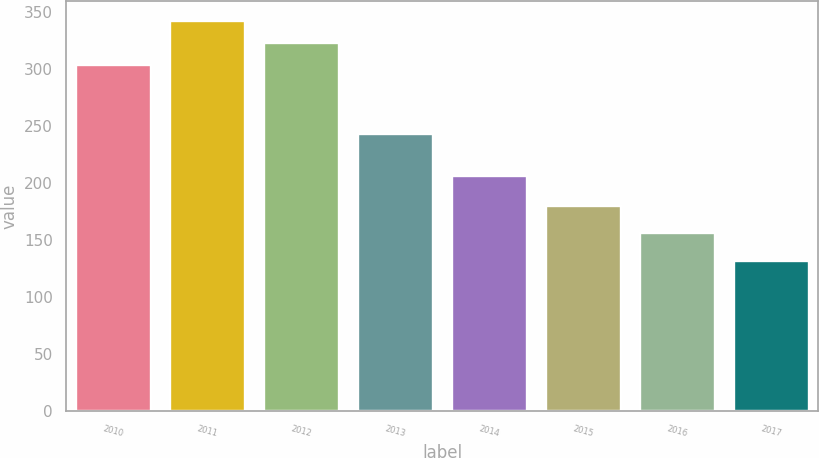Convert chart. <chart><loc_0><loc_0><loc_500><loc_500><bar_chart><fcel>2010<fcel>2011<fcel>2012<fcel>2013<fcel>2014<fcel>2015<fcel>2016<fcel>2017<nl><fcel>304<fcel>342.4<fcel>323.2<fcel>243<fcel>206<fcel>180<fcel>156<fcel>132<nl></chart> 